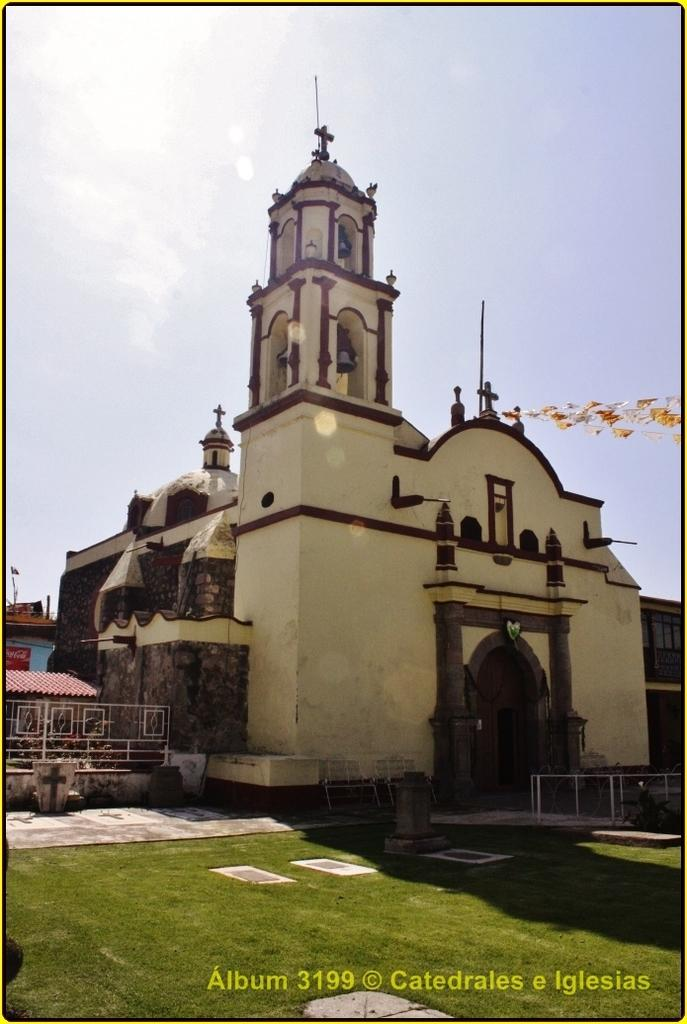What type of structure is present in the image? There is a building in the image. What colors are used on the building? The building has brown and cream colors. What type of vegetation is visible in the image? There is grass in the image. What is the color of the grass? The grass is green. What can be seen in the background of the image? The sky is visible in the background of the image. What is the color of the sky? The sky is white in color. What type of game is being played on the roof of the building in the image? There is no game being played on the roof of the building in the image. What type of creature can be seen interacting with the grass in the image? There are no creatures present in the image; it only features a building, grass, and the sky. 